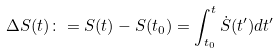Convert formula to latex. <formula><loc_0><loc_0><loc_500><loc_500>\Delta S ( t ) \colon = S ( t ) - S ( t _ { 0 } ) = \int _ { t _ { 0 } } ^ { t } \dot { S } ( t ^ { \prime } ) d t ^ { \prime }</formula> 